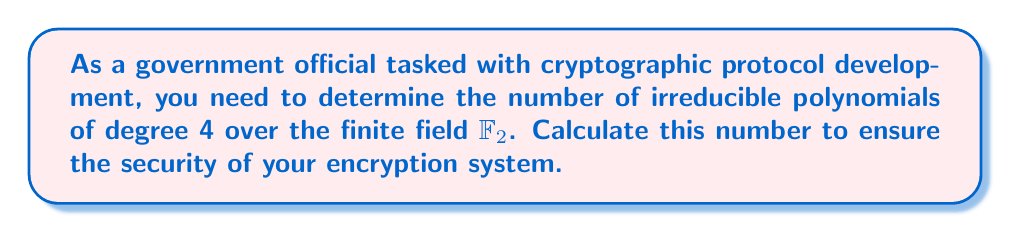What is the answer to this math problem? Let's approach this step-by-step:

1) First, recall the formula for the number of irreducible polynomials of degree $n$ over $\mathbb{F}_q$:

   $$N_q(n) = \frac{1}{n}\sum_{d|n} \mu(d)q^{n/d}$$

   where $\mu(d)$ is the Möbius function.

2) In our case, $q = 2$ (as we're working over $\mathbb{F}_2$) and $n = 4$.

3) The divisors of 4 are 1, 2, and 4. Let's calculate $\mu(d)$ for each:
   
   $\mu(1) = 1$
   $\mu(2) = -1$
   $\mu(4) = 0$

4) Now, let's substitute these into our formula:

   $$N_2(4) = \frac{1}{4}[\mu(1)2^{4/1} + \mu(2)2^{4/2} + \mu(4)2^{4/4}]$$

5) Simplify:

   $$N_2(4) = \frac{1}{4}[1 \cdot 2^4 + (-1) \cdot 2^2 + 0 \cdot 2^1]$$

6) Calculate:

   $$N_2(4) = \frac{1}{4}[16 - 4 + 0] = \frac{12}{4} = 3$$

Therefore, there are 3 irreducible polynomials of degree 4 over $\mathbb{F}_2$.
Answer: 3 